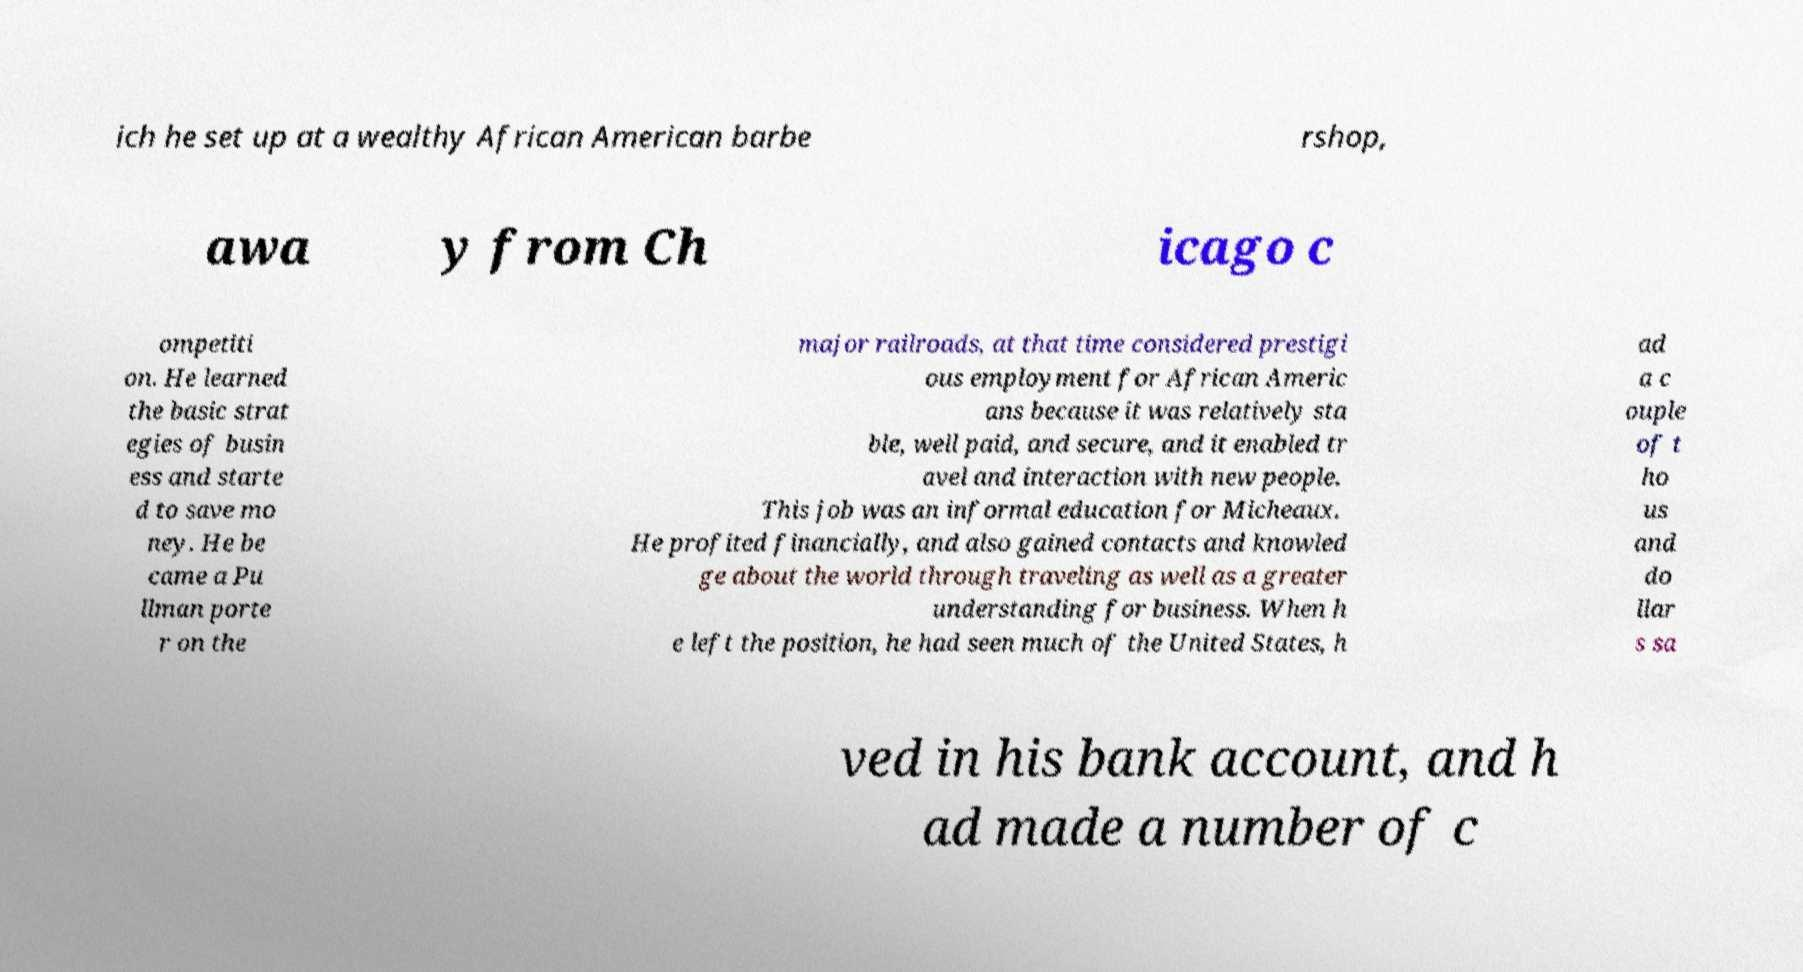Can you read and provide the text displayed in the image?This photo seems to have some interesting text. Can you extract and type it out for me? ich he set up at a wealthy African American barbe rshop, awa y from Ch icago c ompetiti on. He learned the basic strat egies of busin ess and starte d to save mo ney. He be came a Pu llman porte r on the major railroads, at that time considered prestigi ous employment for African Americ ans because it was relatively sta ble, well paid, and secure, and it enabled tr avel and interaction with new people. This job was an informal education for Micheaux. He profited financially, and also gained contacts and knowled ge about the world through traveling as well as a greater understanding for business. When h e left the position, he had seen much of the United States, h ad a c ouple of t ho us and do llar s sa ved in his bank account, and h ad made a number of c 